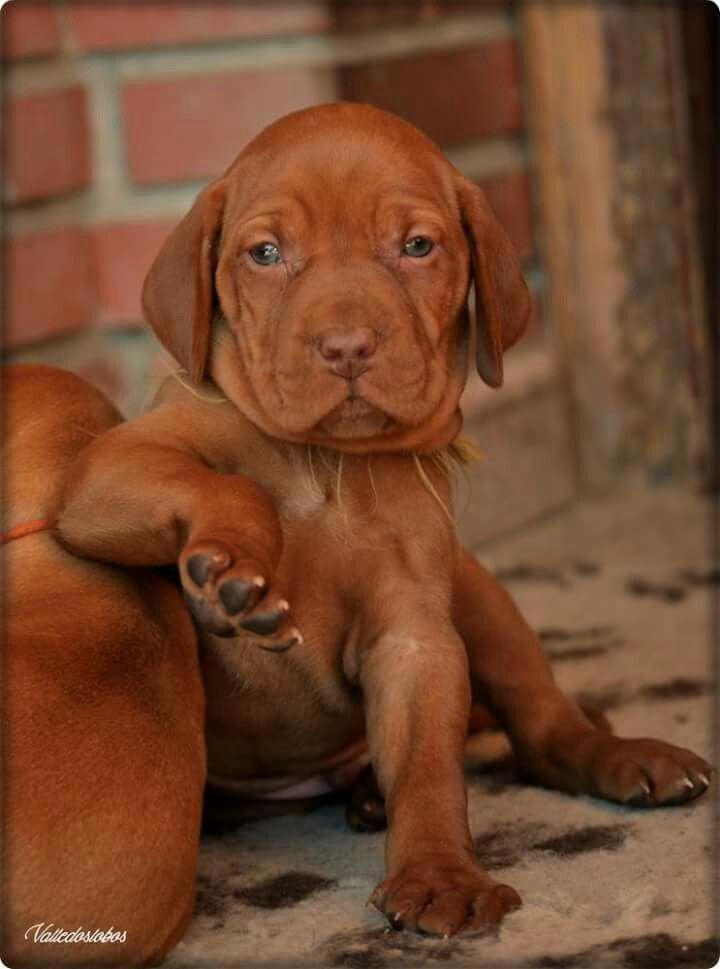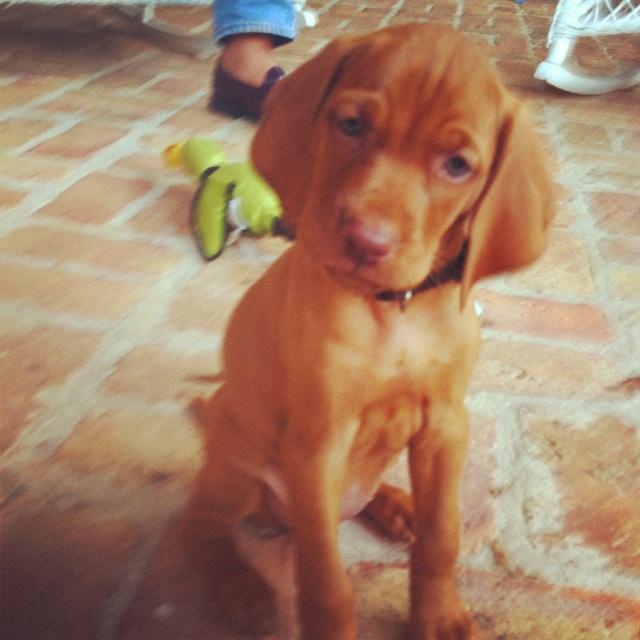The first image is the image on the left, the second image is the image on the right. Assess this claim about the two images: "One image shows a red-orange puppy wearing a collar in an upright sitting pose, and the other image shows a puppy with at least one front paw propped on something off the ground.". Correct or not? Answer yes or no. Yes. 